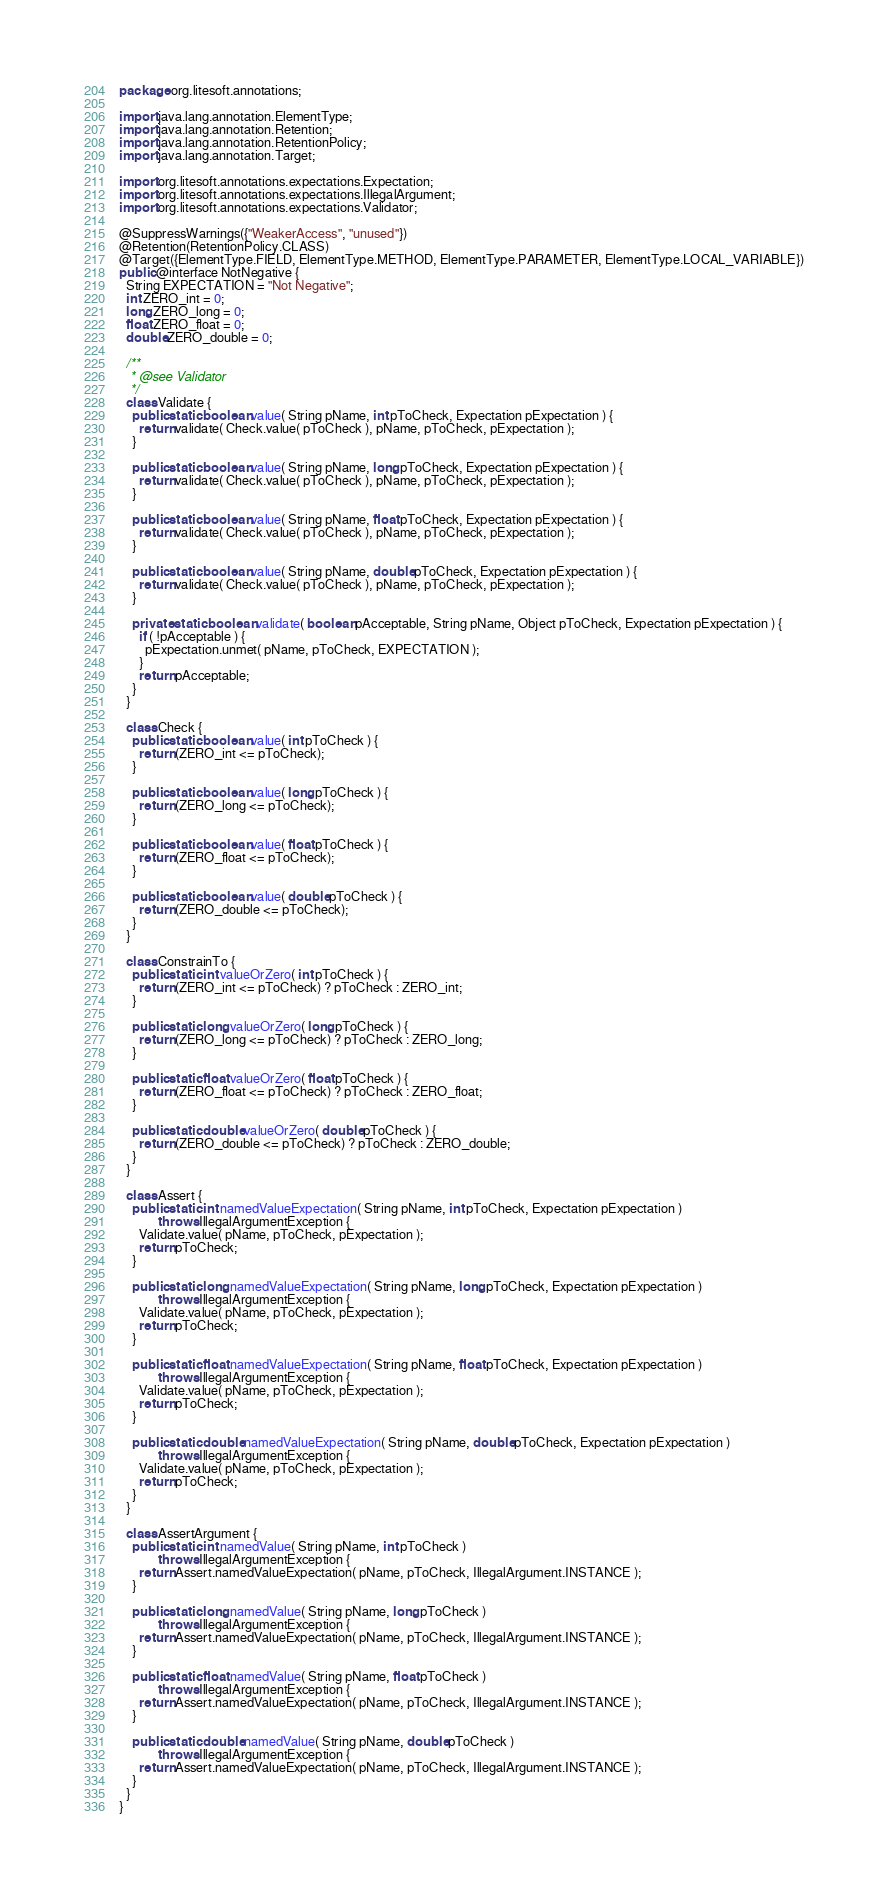<code> <loc_0><loc_0><loc_500><loc_500><_Java_>package org.litesoft.annotations;

import java.lang.annotation.ElementType;
import java.lang.annotation.Retention;
import java.lang.annotation.RetentionPolicy;
import java.lang.annotation.Target;

import org.litesoft.annotations.expectations.Expectation;
import org.litesoft.annotations.expectations.IllegalArgument;
import org.litesoft.annotations.expectations.Validator;

@SuppressWarnings({"WeakerAccess", "unused"})
@Retention(RetentionPolicy.CLASS)
@Target({ElementType.FIELD, ElementType.METHOD, ElementType.PARAMETER, ElementType.LOCAL_VARIABLE})
public @interface NotNegative {
  String EXPECTATION = "Not Negative";
  int ZERO_int = 0;
  long ZERO_long = 0;
  float ZERO_float = 0;
  double ZERO_double = 0;

  /**
   * @see Validator
   */
  class Validate {
    public static boolean value( String pName, int pToCheck, Expectation pExpectation ) {
      return validate( Check.value( pToCheck ), pName, pToCheck, pExpectation );
    }

    public static boolean value( String pName, long pToCheck, Expectation pExpectation ) {
      return validate( Check.value( pToCheck ), pName, pToCheck, pExpectation );
    }

    public static boolean value( String pName, float pToCheck, Expectation pExpectation ) {
      return validate( Check.value( pToCheck ), pName, pToCheck, pExpectation );
    }

    public static boolean value( String pName, double pToCheck, Expectation pExpectation ) {
      return validate( Check.value( pToCheck ), pName, pToCheck, pExpectation );
    }

    private static boolean validate( boolean pAcceptable, String pName, Object pToCheck, Expectation pExpectation ) {
      if ( !pAcceptable ) {
        pExpectation.unmet( pName, pToCheck, EXPECTATION );
      }
      return pAcceptable;
    }
  }

  class Check {
    public static boolean value( int pToCheck ) {
      return (ZERO_int <= pToCheck);
    }

    public static boolean value( long pToCheck ) {
      return (ZERO_long <= pToCheck);
    }

    public static boolean value( float pToCheck ) {
      return (ZERO_float <= pToCheck);
    }

    public static boolean value( double pToCheck ) {
      return (ZERO_double <= pToCheck);
    }
  }

  class ConstrainTo {
    public static int valueOrZero( int pToCheck ) {
      return (ZERO_int <= pToCheck) ? pToCheck : ZERO_int;
    }

    public static long valueOrZero( long pToCheck ) {
      return (ZERO_long <= pToCheck) ? pToCheck : ZERO_long;
    }

    public static float valueOrZero( float pToCheck ) {
      return (ZERO_float <= pToCheck) ? pToCheck : ZERO_float;
    }

    public static double valueOrZero( double pToCheck ) {
      return (ZERO_double <= pToCheck) ? pToCheck : ZERO_double;
    }
  }

  class Assert {
    public static int namedValueExpectation( String pName, int pToCheck, Expectation pExpectation )
            throws IllegalArgumentException {
      Validate.value( pName, pToCheck, pExpectation );
      return pToCheck;
    }

    public static long namedValueExpectation( String pName, long pToCheck, Expectation pExpectation )
            throws IllegalArgumentException {
      Validate.value( pName, pToCheck, pExpectation );
      return pToCheck;
    }

    public static float namedValueExpectation( String pName, float pToCheck, Expectation pExpectation )
            throws IllegalArgumentException {
      Validate.value( pName, pToCheck, pExpectation );
      return pToCheck;
    }

    public static double namedValueExpectation( String pName, double pToCheck, Expectation pExpectation )
            throws IllegalArgumentException {
      Validate.value( pName, pToCheck, pExpectation );
      return pToCheck;
    }
  }

  class AssertArgument {
    public static int namedValue( String pName, int pToCheck )
            throws IllegalArgumentException {
      return Assert.namedValueExpectation( pName, pToCheck, IllegalArgument.INSTANCE );
    }

    public static long namedValue( String pName, long pToCheck )
            throws IllegalArgumentException {
      return Assert.namedValueExpectation( pName, pToCheck, IllegalArgument.INSTANCE );
    }

    public static float namedValue( String pName, float pToCheck )
            throws IllegalArgumentException {
      return Assert.namedValueExpectation( pName, pToCheck, IllegalArgument.INSTANCE );
    }

    public static double namedValue( String pName, double pToCheck )
            throws IllegalArgumentException {
      return Assert.namedValueExpectation( pName, pToCheck, IllegalArgument.INSTANCE );
    }
  }
}
</code> 